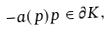<formula> <loc_0><loc_0><loc_500><loc_500>- a ( p ) p \in \partial K ,</formula> 